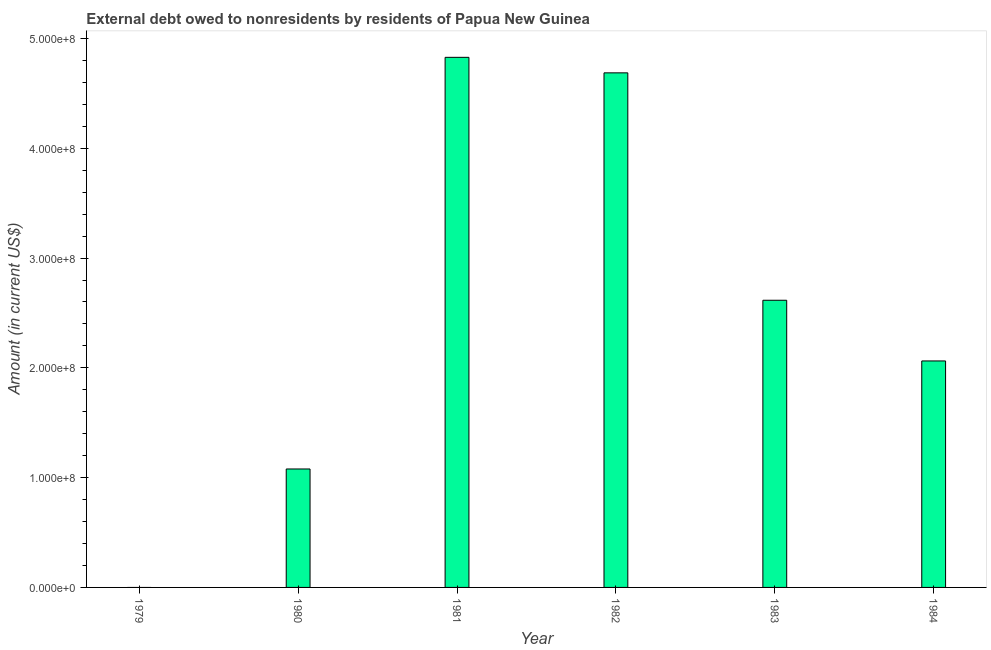Does the graph contain any zero values?
Provide a succinct answer. Yes. What is the title of the graph?
Provide a succinct answer. External debt owed to nonresidents by residents of Papua New Guinea. Across all years, what is the maximum debt?
Offer a terse response. 4.83e+08. What is the sum of the debt?
Your answer should be very brief. 1.53e+09. What is the difference between the debt in 1980 and 1983?
Offer a very short reply. -1.54e+08. What is the average debt per year?
Offer a very short reply. 2.55e+08. What is the median debt?
Offer a terse response. 2.34e+08. In how many years, is the debt greater than 340000000 US$?
Keep it short and to the point. 2. What is the ratio of the debt in 1980 to that in 1984?
Provide a short and direct response. 0.52. What is the difference between the highest and the second highest debt?
Offer a very short reply. 1.41e+07. Is the sum of the debt in 1981 and 1982 greater than the maximum debt across all years?
Your answer should be compact. Yes. What is the difference between the highest and the lowest debt?
Give a very brief answer. 4.83e+08. How many bars are there?
Keep it short and to the point. 5. Are all the bars in the graph horizontal?
Offer a very short reply. No. What is the Amount (in current US$) of 1980?
Offer a terse response. 1.08e+08. What is the Amount (in current US$) of 1981?
Keep it short and to the point. 4.83e+08. What is the Amount (in current US$) in 1982?
Provide a short and direct response. 4.69e+08. What is the Amount (in current US$) in 1983?
Provide a short and direct response. 2.62e+08. What is the Amount (in current US$) of 1984?
Your response must be concise. 2.06e+08. What is the difference between the Amount (in current US$) in 1980 and 1981?
Provide a short and direct response. -3.75e+08. What is the difference between the Amount (in current US$) in 1980 and 1982?
Provide a succinct answer. -3.61e+08. What is the difference between the Amount (in current US$) in 1980 and 1983?
Ensure brevity in your answer.  -1.54e+08. What is the difference between the Amount (in current US$) in 1980 and 1984?
Provide a short and direct response. -9.84e+07. What is the difference between the Amount (in current US$) in 1981 and 1982?
Offer a very short reply. 1.41e+07. What is the difference between the Amount (in current US$) in 1981 and 1983?
Offer a terse response. 2.21e+08. What is the difference between the Amount (in current US$) in 1981 and 1984?
Offer a terse response. 2.77e+08. What is the difference between the Amount (in current US$) in 1982 and 1983?
Provide a succinct answer. 2.07e+08. What is the difference between the Amount (in current US$) in 1982 and 1984?
Offer a very short reply. 2.62e+08. What is the difference between the Amount (in current US$) in 1983 and 1984?
Make the answer very short. 5.53e+07. What is the ratio of the Amount (in current US$) in 1980 to that in 1981?
Ensure brevity in your answer.  0.22. What is the ratio of the Amount (in current US$) in 1980 to that in 1982?
Provide a succinct answer. 0.23. What is the ratio of the Amount (in current US$) in 1980 to that in 1983?
Your answer should be compact. 0.41. What is the ratio of the Amount (in current US$) in 1980 to that in 1984?
Ensure brevity in your answer.  0.52. What is the ratio of the Amount (in current US$) in 1981 to that in 1982?
Give a very brief answer. 1.03. What is the ratio of the Amount (in current US$) in 1981 to that in 1983?
Give a very brief answer. 1.85. What is the ratio of the Amount (in current US$) in 1981 to that in 1984?
Your answer should be compact. 2.34. What is the ratio of the Amount (in current US$) in 1982 to that in 1983?
Make the answer very short. 1.79. What is the ratio of the Amount (in current US$) in 1982 to that in 1984?
Your answer should be very brief. 2.27. What is the ratio of the Amount (in current US$) in 1983 to that in 1984?
Offer a very short reply. 1.27. 